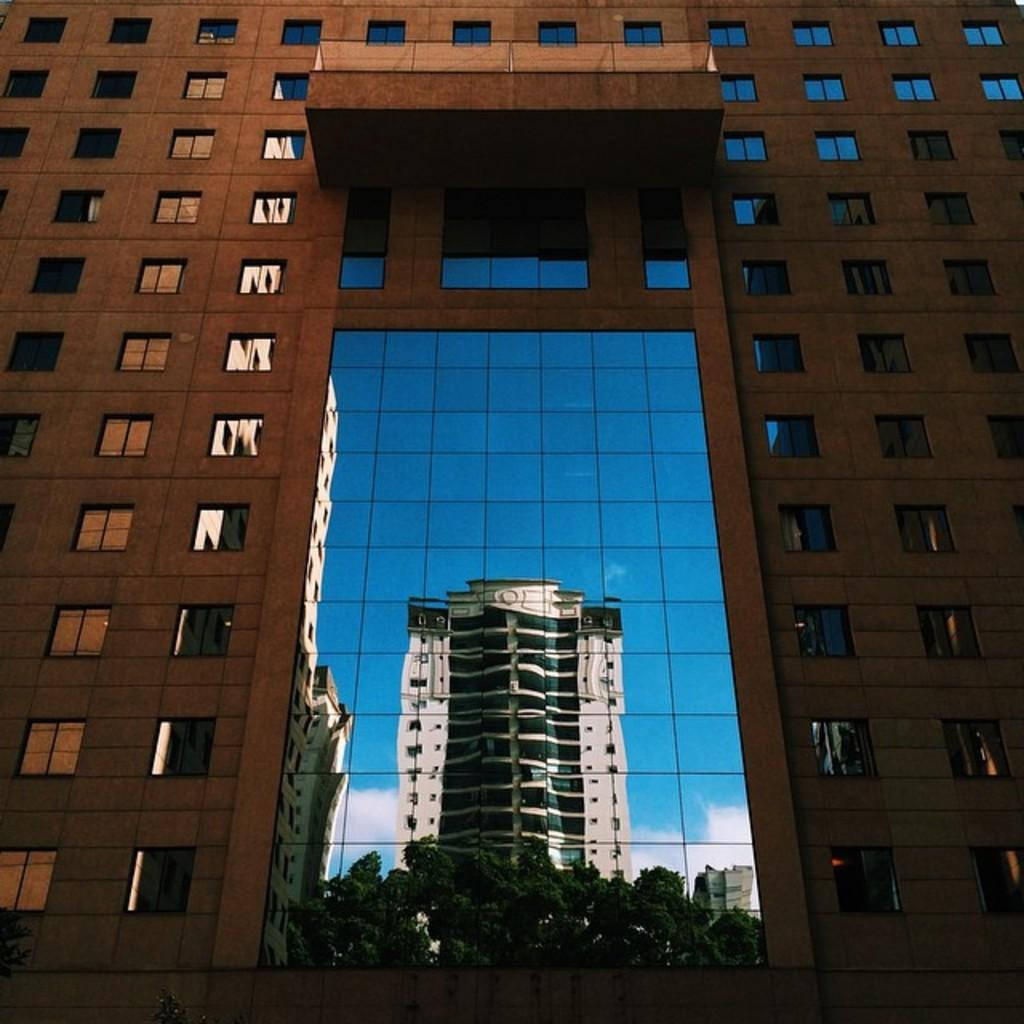What type of structure is present in the image? There is a building in the image. What material is featured in the image? There is glass in the image. What can be seen through the glass in the image? Buildings, trees, and the sky are visible through the glass. What is the condition of the sky in the image? Clouds are present in the sky. What type of office can be seen through the glass in the image? There is no office visible through the glass in the image. Is there a house visible through the glass in the image? There is no house visible through the glass in the image. 